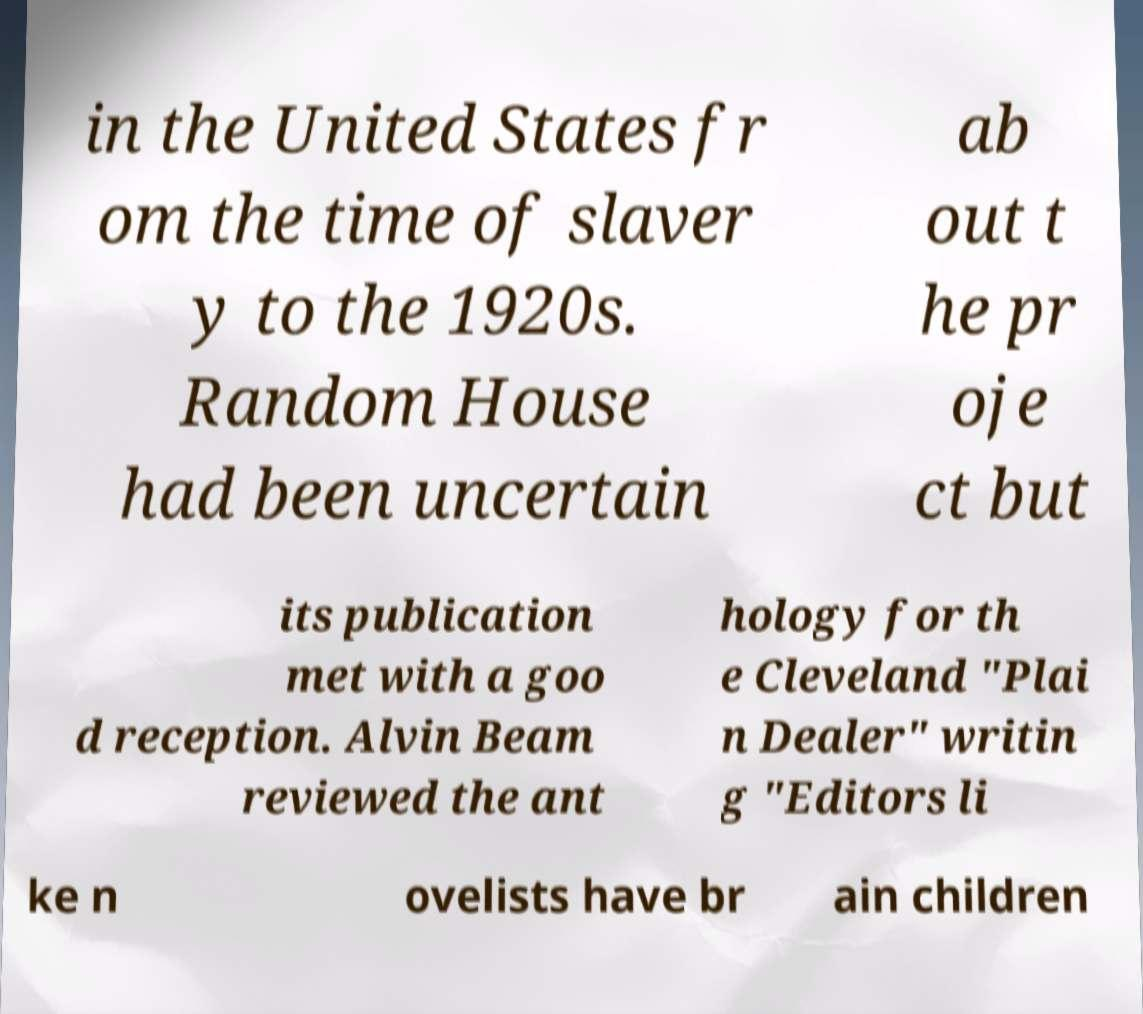Could you assist in decoding the text presented in this image and type it out clearly? in the United States fr om the time of slaver y to the 1920s. Random House had been uncertain ab out t he pr oje ct but its publication met with a goo d reception. Alvin Beam reviewed the ant hology for th e Cleveland "Plai n Dealer" writin g "Editors li ke n ovelists have br ain children 